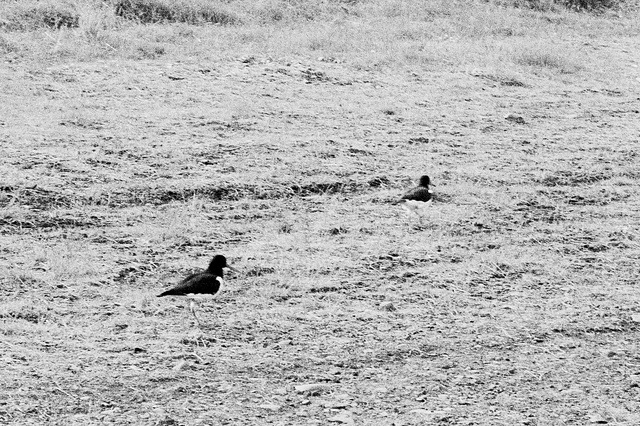Describe the objects in this image and their specific colors. I can see bird in darkgray, black, lightgray, and gray tones and bird in darkgray, black, lightgray, and gray tones in this image. 